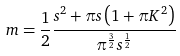<formula> <loc_0><loc_0><loc_500><loc_500>m = \frac { 1 } { 2 } \frac { s ^ { 2 } + \pi s \left ( 1 + \pi K ^ { 2 } \right ) } { \pi ^ { \frac { 3 } { 2 } } s ^ { \frac { 1 } { 2 } } }</formula> 